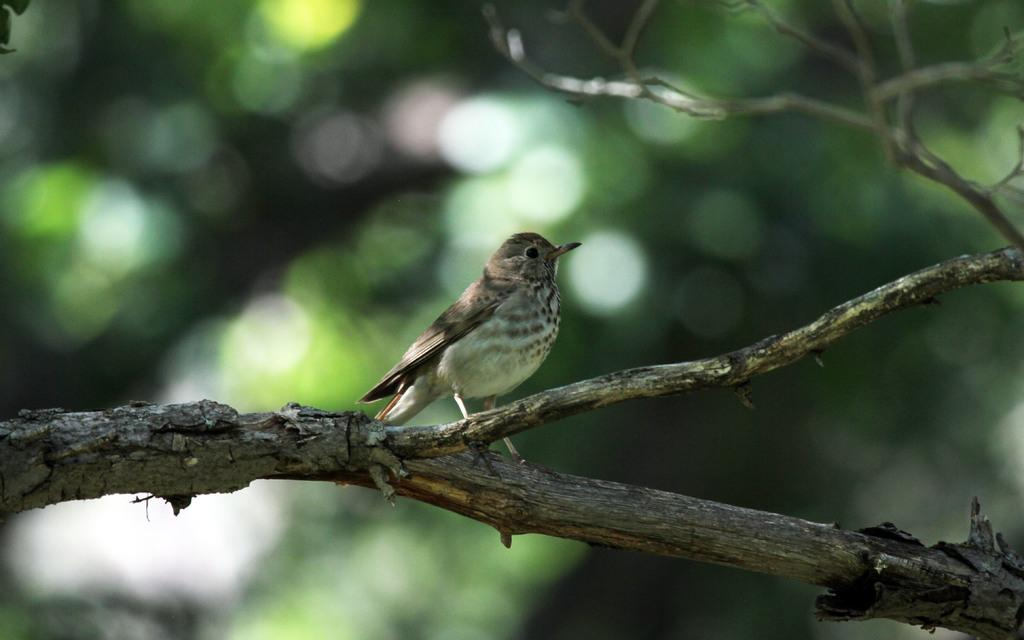What type of animal can be seen in the image? There is a bird in the image. Where is the bird located in the image? The bird is standing on the stem of a tree. What type of test is being conducted in the image? There is no test being conducted in the image; it features a bird standing on the stem of a tree. What kind of humor can be found in the image? There is no humor present in the image; it is a straightforward depiction of a bird on a tree. 